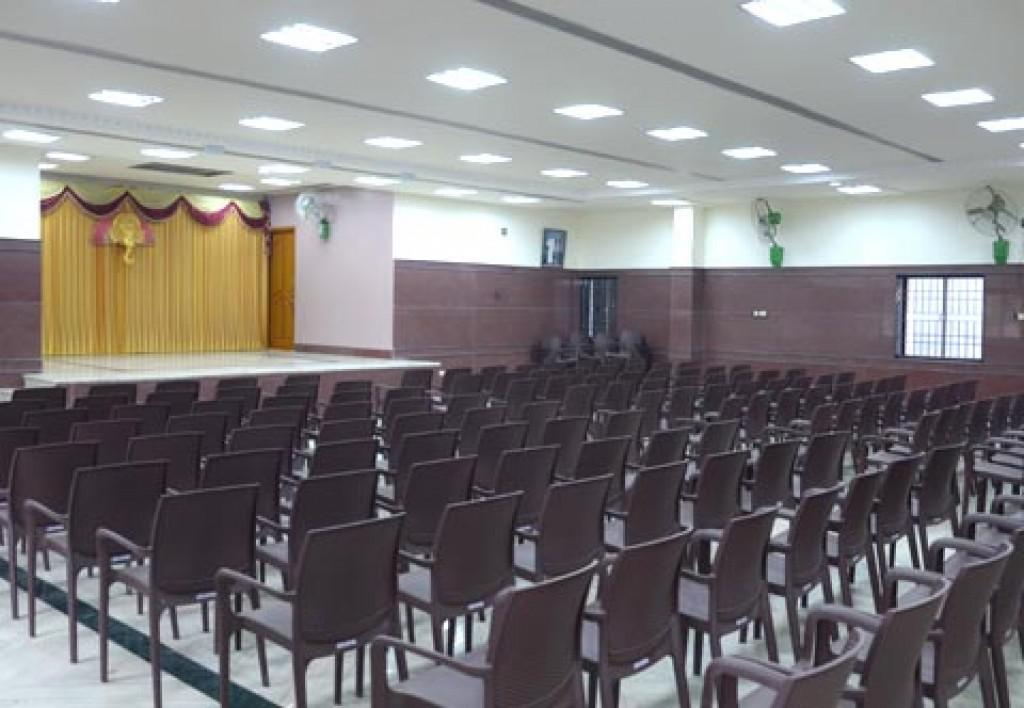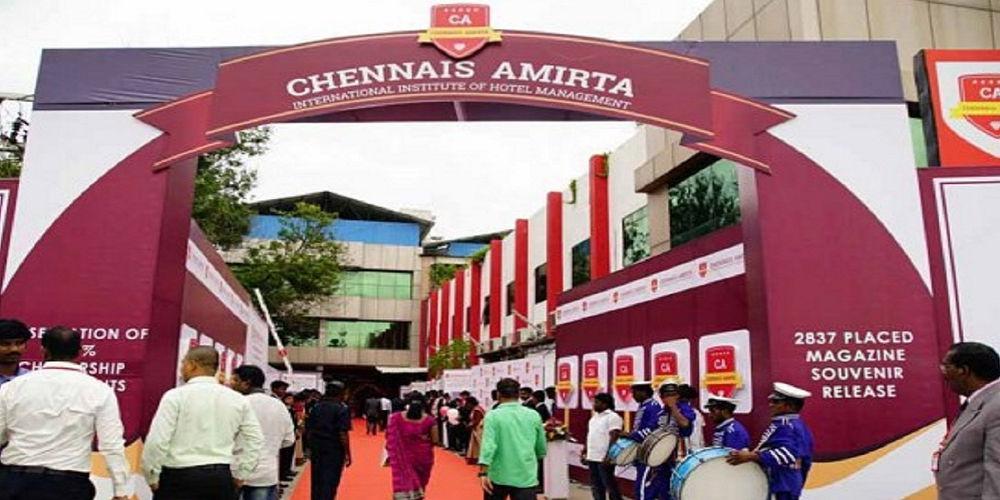The first image is the image on the left, the second image is the image on the right. For the images shown, is this caption "there is a bakery with a star shape on their sign and black framed windows" true? Answer yes or no. No. The first image is the image on the left, the second image is the image on the right. Evaluate the accuracy of this statement regarding the images: "An exterior view shows a star shape near lettering above a square opening in the right image.". Is it true? Answer yes or no. No. 